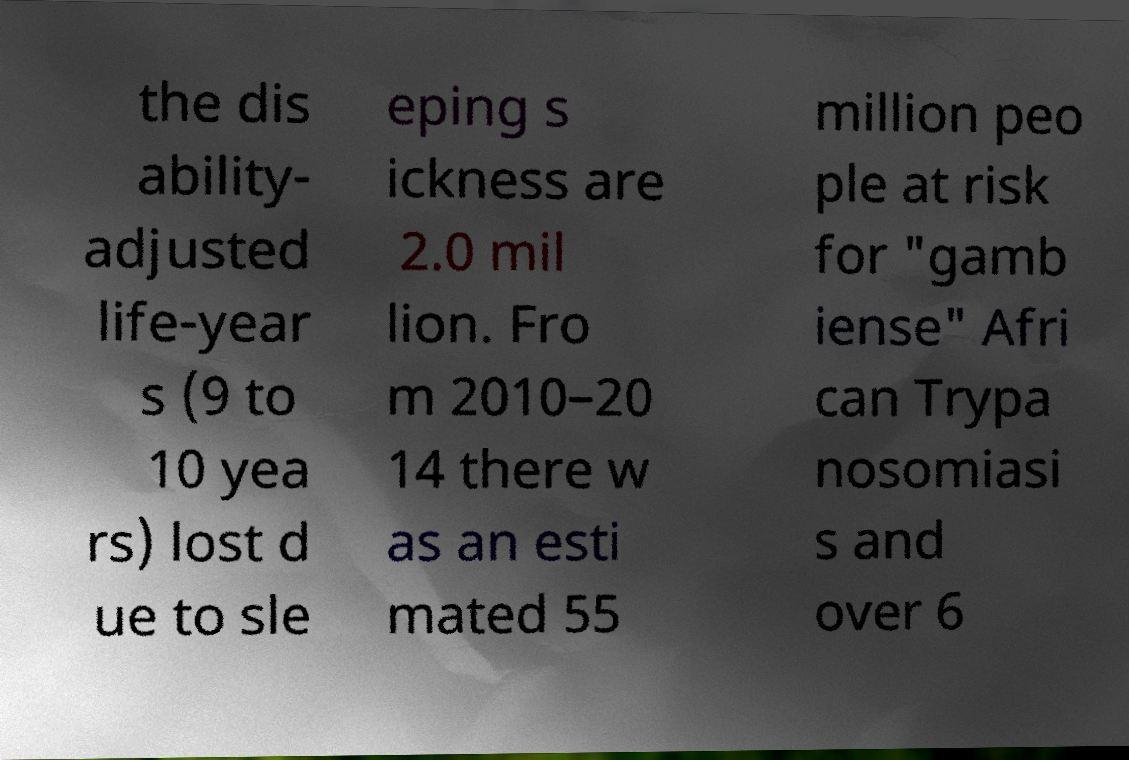Please read and relay the text visible in this image. What does it say? the dis ability- adjusted life-year s (9 to 10 yea rs) lost d ue to sle eping s ickness are 2.0 mil lion. Fro m 2010–20 14 there w as an esti mated 55 million peo ple at risk for "gamb iense" Afri can Trypa nosomiasi s and over 6 